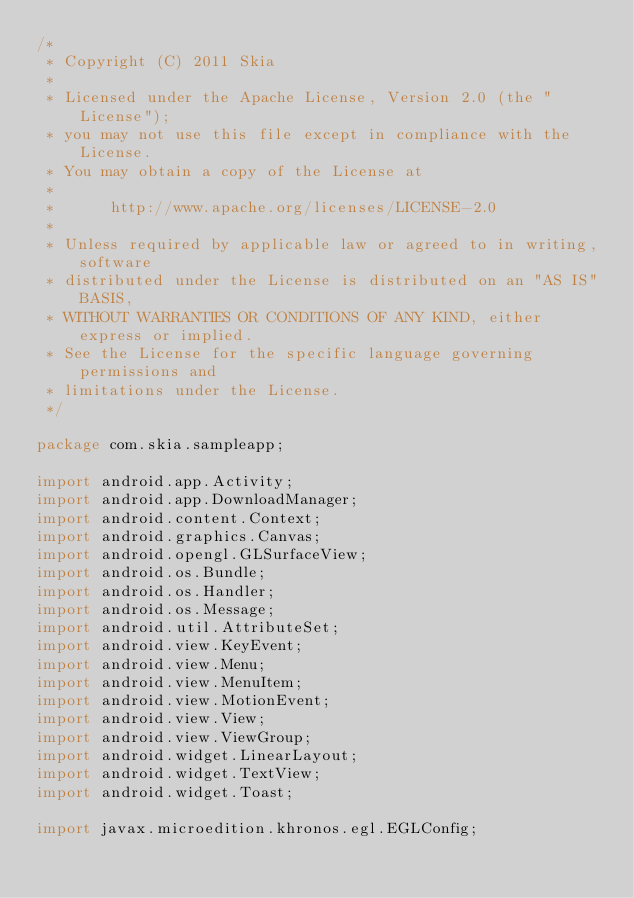Convert code to text. <code><loc_0><loc_0><loc_500><loc_500><_Java_>/*
 * Copyright (C) 2011 Skia
 *
 * Licensed under the Apache License, Version 2.0 (the "License");
 * you may not use this file except in compliance with the License.
 * You may obtain a copy of the License at
 *
 *      http://www.apache.org/licenses/LICENSE-2.0
 *
 * Unless required by applicable law or agreed to in writing, software
 * distributed under the License is distributed on an "AS IS" BASIS,
 * WITHOUT WARRANTIES OR CONDITIONS OF ANY KIND, either express or implied.
 * See the License for the specific language governing permissions and
 * limitations under the License.
 */

package com.skia.sampleapp;

import android.app.Activity;
import android.app.DownloadManager;
import android.content.Context;
import android.graphics.Canvas;
import android.opengl.GLSurfaceView;
import android.os.Bundle;
import android.os.Handler;
import android.os.Message;
import android.util.AttributeSet;
import android.view.KeyEvent;
import android.view.Menu;
import android.view.MenuItem;
import android.view.MotionEvent;
import android.view.View;
import android.view.ViewGroup;
import android.widget.LinearLayout;
import android.widget.TextView;
import android.widget.Toast;

import javax.microedition.khronos.egl.EGLConfig;</code> 